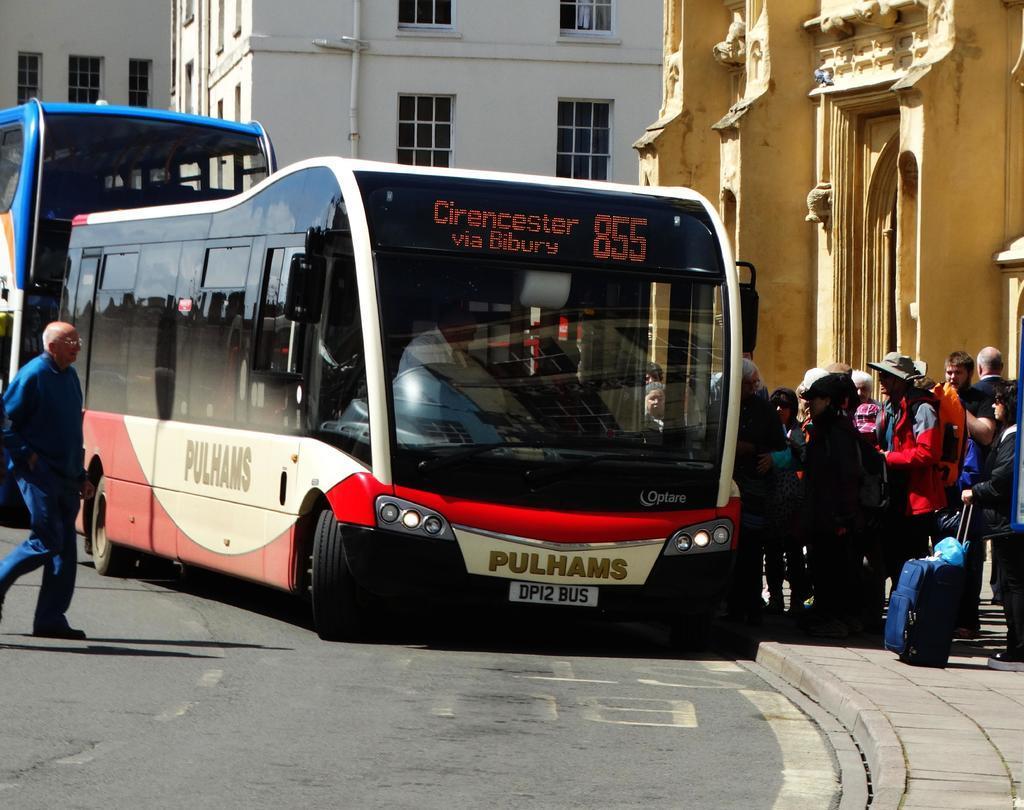Could you give a brief overview of what you see in this image? In the center of the image there is a bus on the road. On the right side of the image we can see persons on the footpath. In the background we can see buildings. 